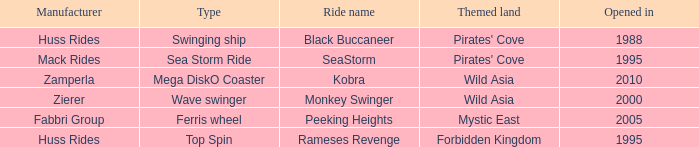What type ride is Wild Asia that opened in 2000? Wave swinger. 